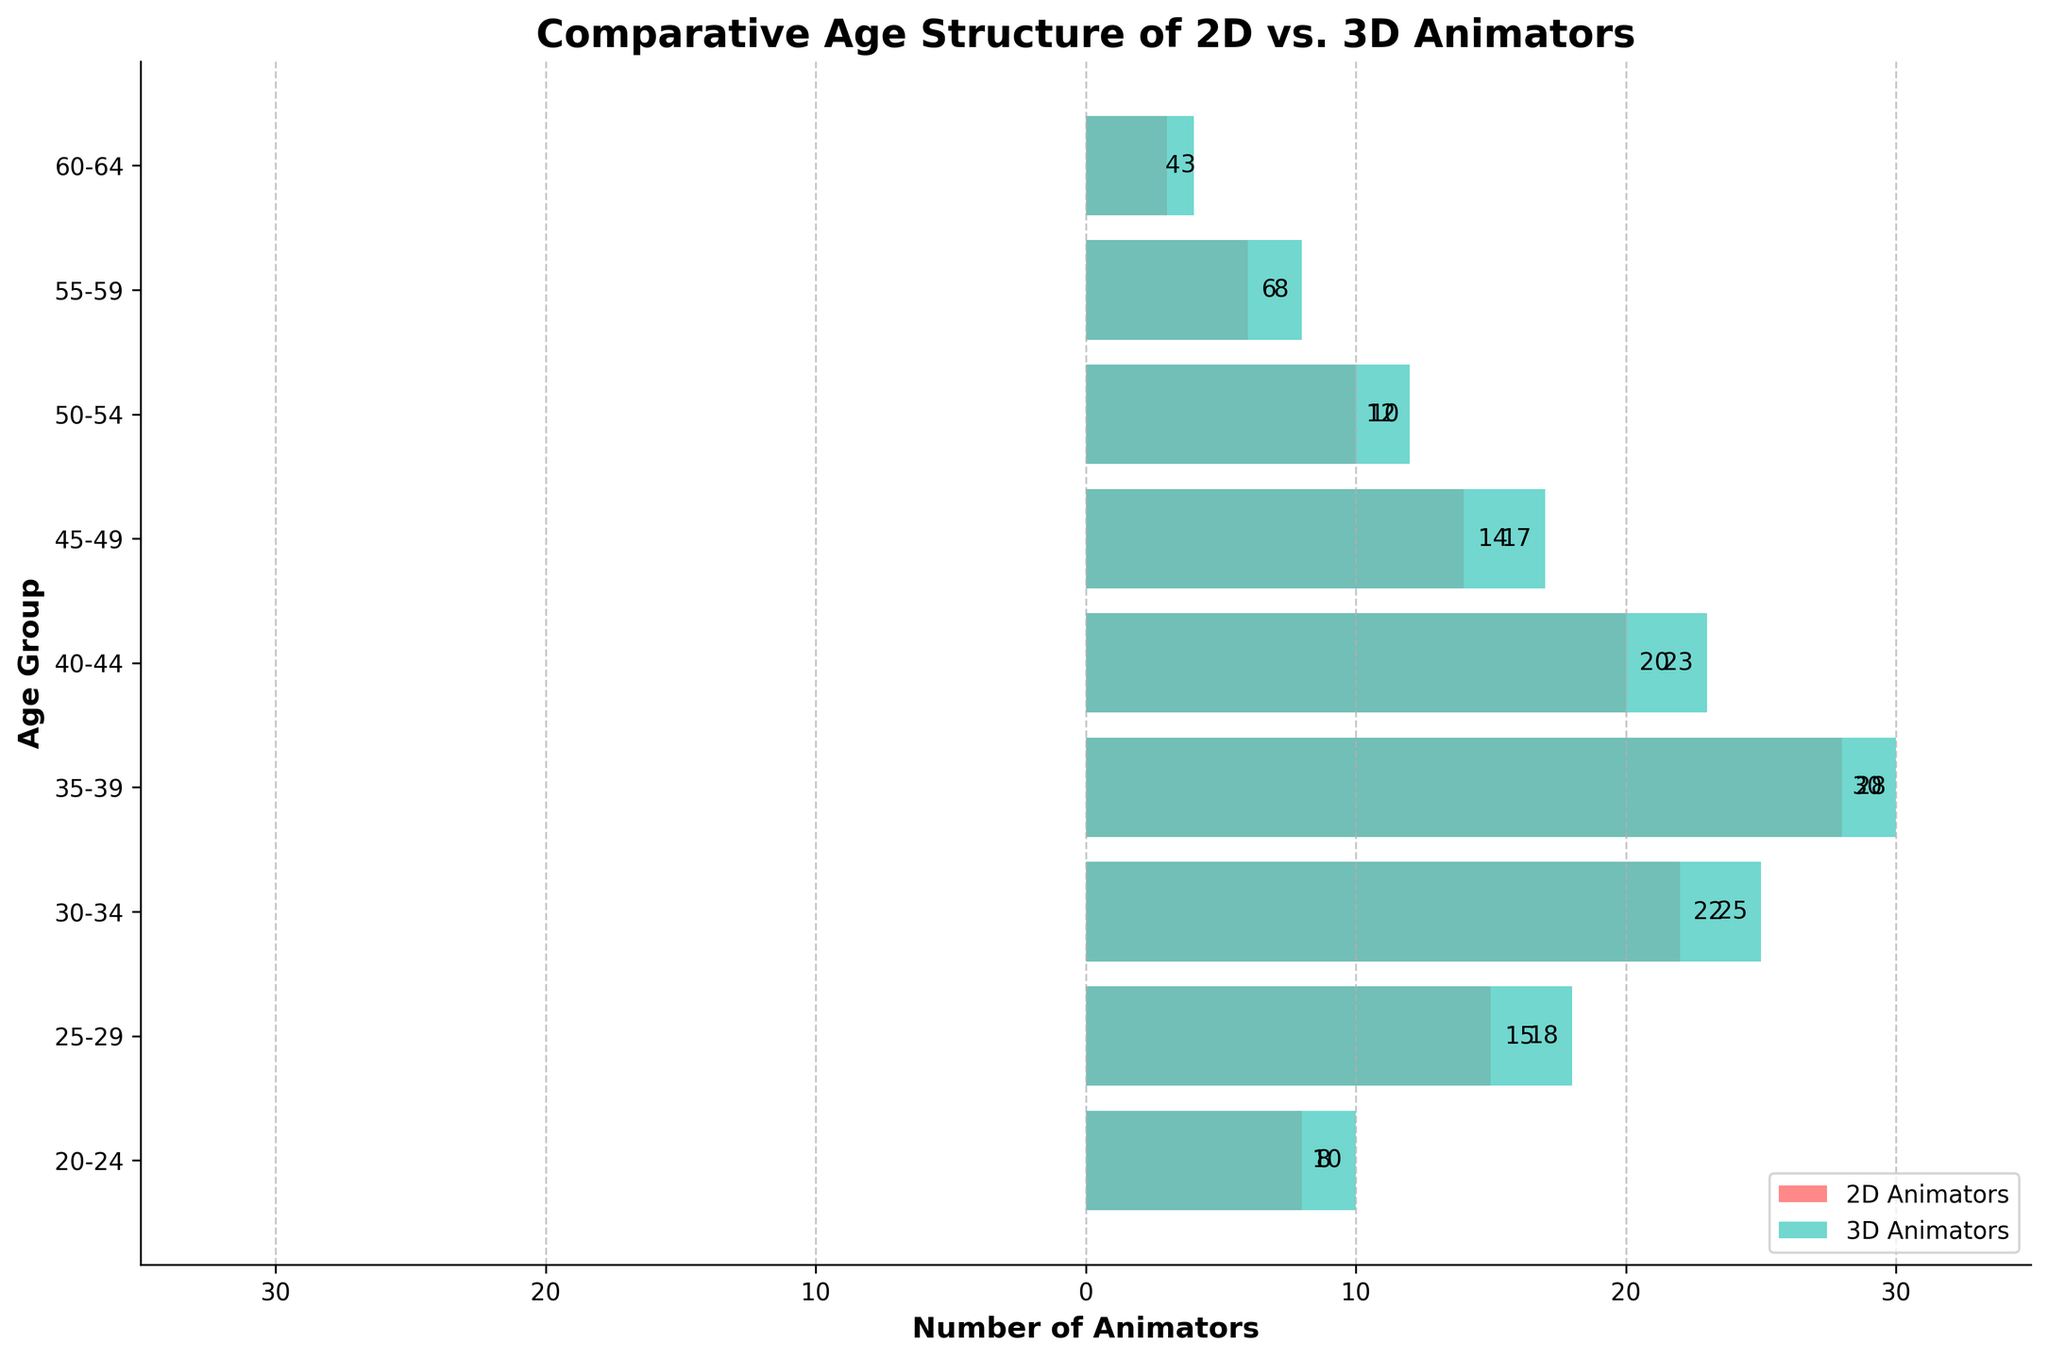What is the title of the figure? The title can be found at the top of the figure, which summarises the main topic of the plot.
Answer: Comparative Age Structure of 2D vs. 3D Animators What is the age group with the highest number of 2D animators? By examining the lengths of the bars corresponding to 2D animators, the longest bar will indicate the age group with the highest number of 2D animators.
Answer: 35-39 How many more 3D animators are there in the 30-34 age group compared to 20-24? Subtract the number of 3D animators in the 20-24 age group (-10) from the number in the 30-34 age group (-25). The absolute values are used for counts.
Answer: 15 What is the total number of 2D animators represented in the plot? Sum the values of 2D animators across all age groups: 8 + 15 + 22 + 28 + 20 + 14 + 10 + 6 + 3.
Answer: 126 In which age group is the difference between the number of 2D and 3D animators the smallest? Calculate the absolute difference in numbers between 2D and 3D animators for each age group and find the smallest difference:
Answer: 60-64 Between the ages of 40-44, which type of animator is more prevalent and by how much? Compare the number of 2D animators (20) to 3D animators (23). Subtract the smaller number from the larger one.
Answer: 3D Animators by 3 What’s the combined number of animators aged 50-54, for both 2D and 3D? Add the number of 2D animators (10) to the number of 3D animators (12).
Answer: 22 What color represents the 3D animators in the graph? The color corresponding to the 3D animators on the right side of the plot needs to be identified.
Answer: Teal Which age group has the fewest total animators and what is their combined count? First, find the sum of 2D and 3D animators for each age group, then identify the smallest sum.
Answer: 60-64 with 7 animators 